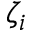<formula> <loc_0><loc_0><loc_500><loc_500>\zeta _ { i }</formula> 